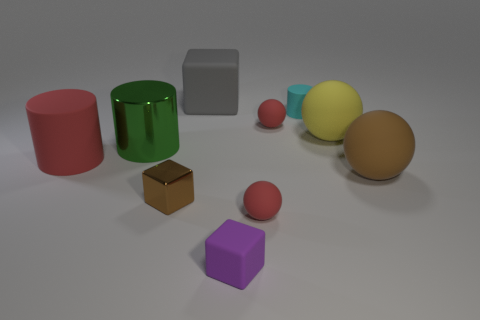Subtract all green cubes. How many red spheres are left? 2 Subtract all cyan balls. Subtract all purple blocks. How many balls are left? 4 Subtract all spheres. How many objects are left? 6 Add 2 green shiny cylinders. How many green shiny cylinders are left? 3 Add 5 tiny red metallic cubes. How many tiny red metallic cubes exist? 5 Subtract 0 green blocks. How many objects are left? 10 Subtract all yellow rubber spheres. Subtract all large gray rubber cubes. How many objects are left? 8 